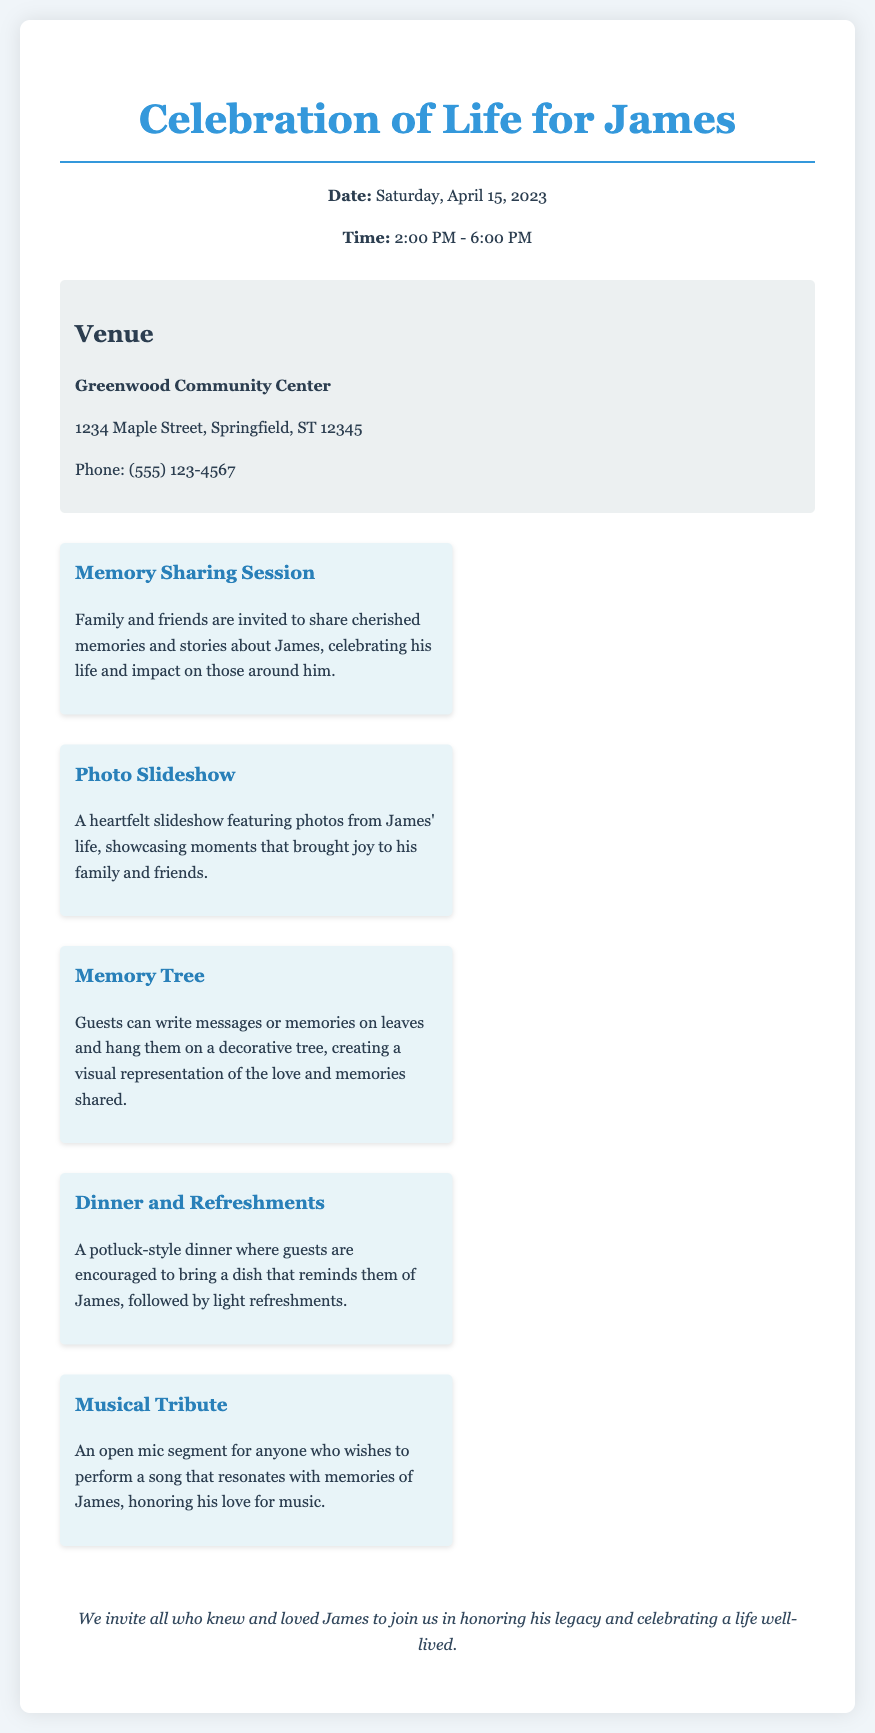What is the date of the celebration? The date of the celebration is clearly stated in the event details section of the document.
Answer: Saturday, April 15, 2023 What is the time for the event? The time for the event is provided in the event details section, indicating when it starts and ends.
Answer: 2:00 PM - 6:00 PM Where will the gathering be held? The venue is named in the document, specifying where the gathering will take place.
Answer: Greenwood Community Center What is one of the activities listed in the memo? The memo outlines several activities planned for the event, providing a brief description of each.
Answer: Memory Sharing Session What type of dinner will be served? The document specifies the style of dinner being offered at the event.
Answer: Potluck-style dinner How can guests honor James' love for music? The memo details specific activities that allow guests to engage with memories related to James, including music.
Answer: Musical Tribute What is the address of the venue? The venue information includes an address where the gathering will take place.
Answer: 1234 Maple Street, Springfield, ST 12345 What is the purpose of the Memory Tree activity? The document describes the significance of the Memory Tree activity in honoring James' legacy.
Answer: Visual representation of love and memories shared What is the main theme of the gathering? The overall purpose of the event is highlighted in the closing statement of the document.
Answer: Honoring James' legacy 